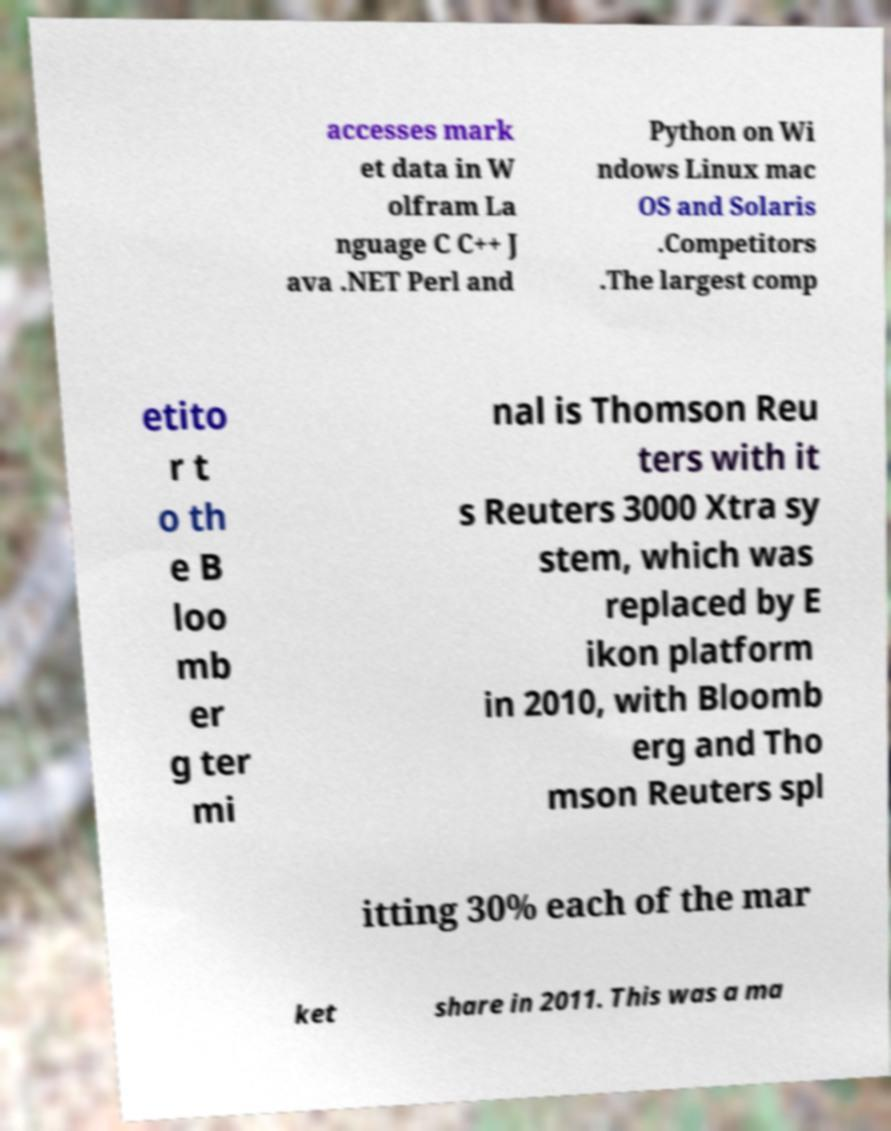Please identify and transcribe the text found in this image. accesses mark et data in W olfram La nguage C C++ J ava .NET Perl and Python on Wi ndows Linux mac OS and Solaris .Competitors .The largest comp etito r t o th e B loo mb er g ter mi nal is Thomson Reu ters with it s Reuters 3000 Xtra sy stem, which was replaced by E ikon platform in 2010, with Bloomb erg and Tho mson Reuters spl itting 30% each of the mar ket share in 2011. This was a ma 